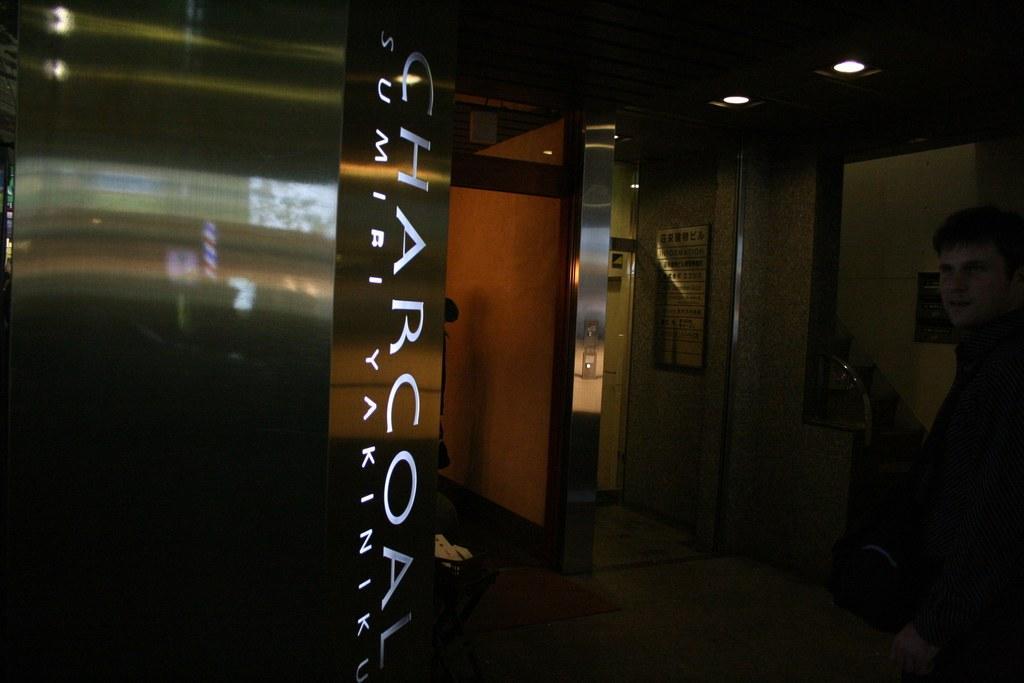Describe this image in one or two sentences. In this image, we can see a person and in the background, there are boards, lights and there is a wall. At the bottom, there is a floor. 